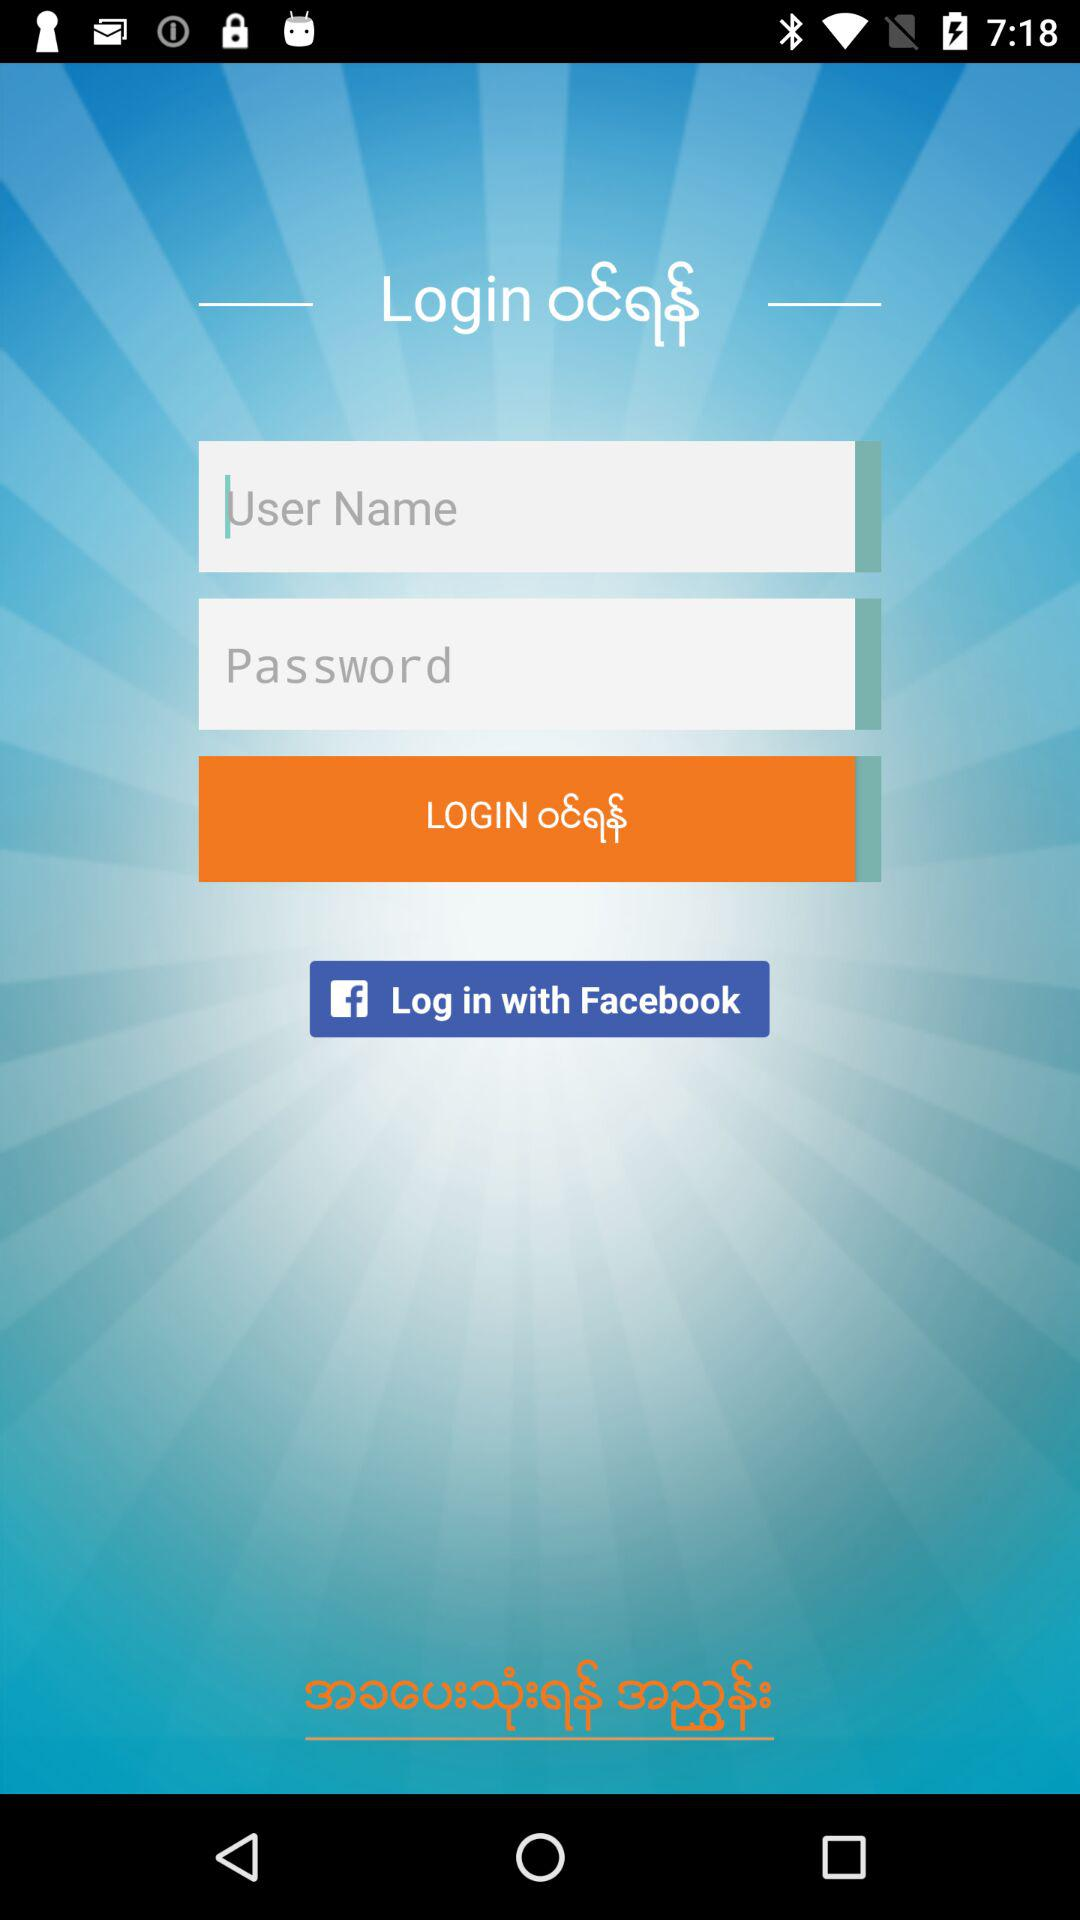How many text input fields are there on this screen?
Answer the question using a single word or phrase. 2 